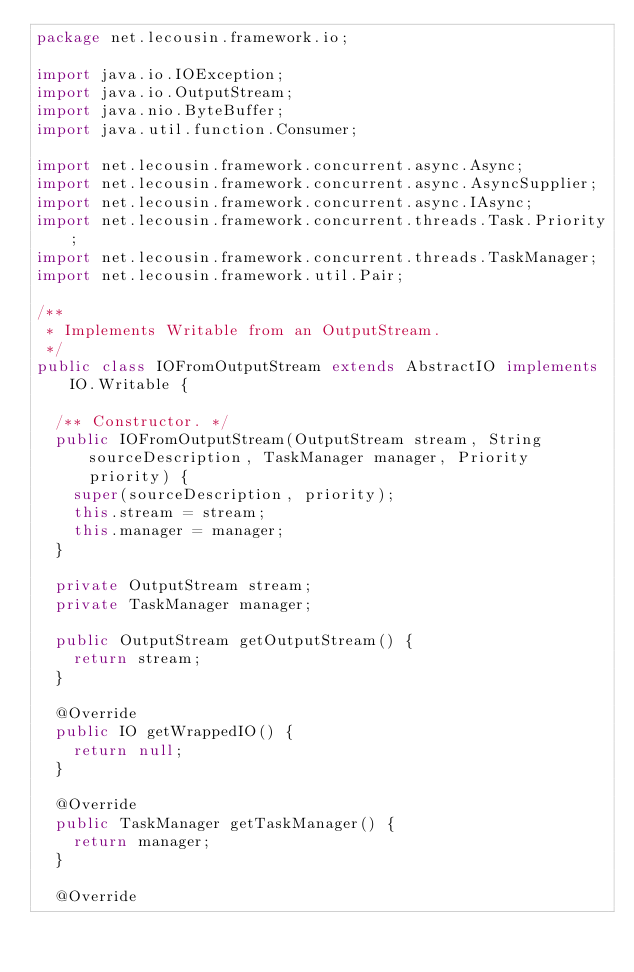<code> <loc_0><loc_0><loc_500><loc_500><_Java_>package net.lecousin.framework.io;

import java.io.IOException;
import java.io.OutputStream;
import java.nio.ByteBuffer;
import java.util.function.Consumer;

import net.lecousin.framework.concurrent.async.Async;
import net.lecousin.framework.concurrent.async.AsyncSupplier;
import net.lecousin.framework.concurrent.async.IAsync;
import net.lecousin.framework.concurrent.threads.Task.Priority;
import net.lecousin.framework.concurrent.threads.TaskManager;
import net.lecousin.framework.util.Pair;

/**
 * Implements Writable from an OutputStream.
 */
public class IOFromOutputStream extends AbstractIO implements IO.Writable {

	/** Constructor. */
	public IOFromOutputStream(OutputStream stream, String sourceDescription, TaskManager manager, Priority priority) {
		super(sourceDescription, priority);
		this.stream = stream;
		this.manager = manager;
	}
	
	private OutputStream stream;
	private TaskManager manager;
	
	public OutputStream getOutputStream() {
		return stream;
	}
	
	@Override
	public IO getWrappedIO() {
		return null;
	}
	
	@Override
	public TaskManager getTaskManager() {
		return manager;
	}
	
	@Override</code> 